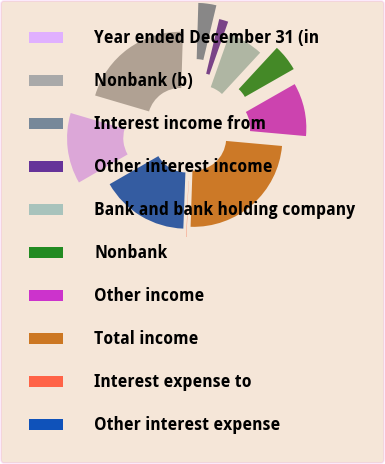Convert chart. <chart><loc_0><loc_0><loc_500><loc_500><pie_chart><fcel>Year ended December 31 (in<fcel>Nonbank (b)<fcel>Interest income from<fcel>Other interest income<fcel>Bank and bank holding company<fcel>Nonbank<fcel>Other income<fcel>Total income<fcel>Interest expense to<fcel>Other interest expense<nl><fcel>12.88%<fcel>20.9%<fcel>3.27%<fcel>1.67%<fcel>6.47%<fcel>4.87%<fcel>9.68%<fcel>24.1%<fcel>0.06%<fcel>16.09%<nl></chart> 